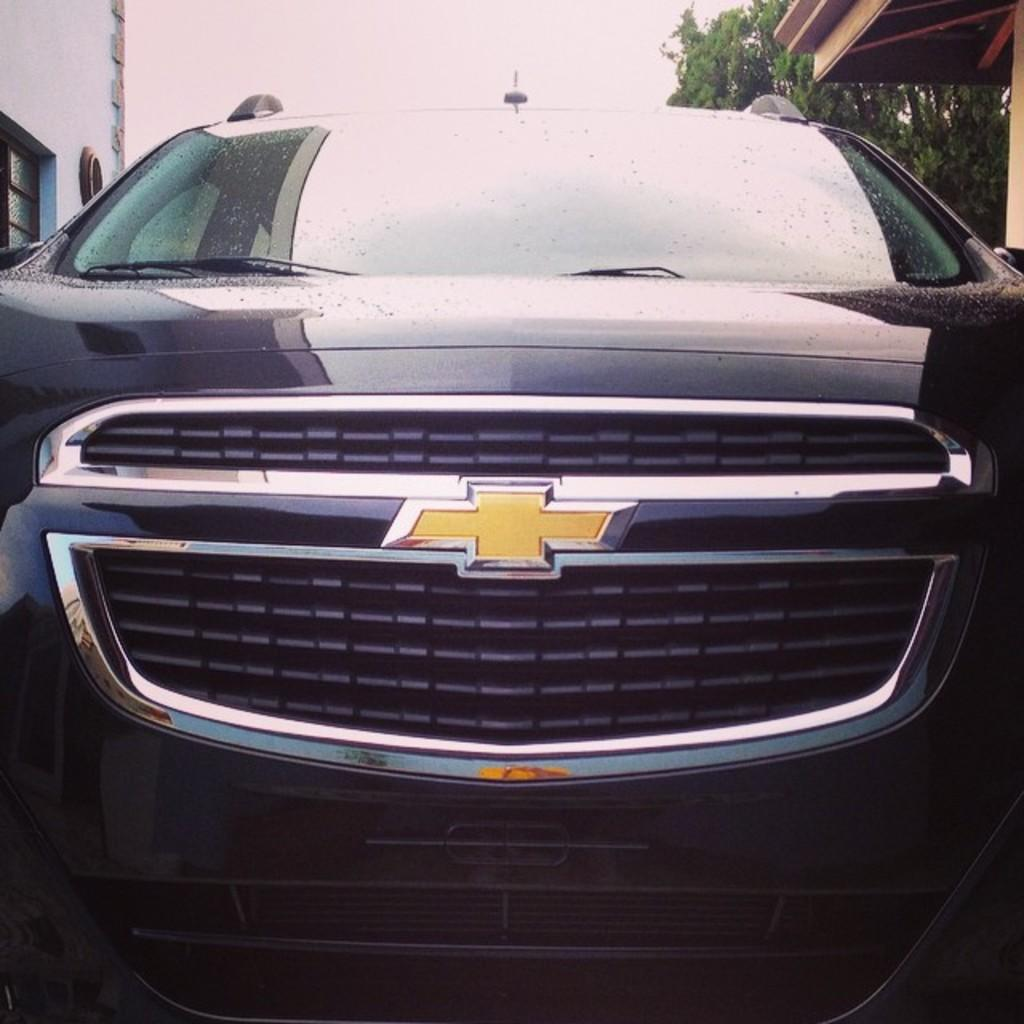What is the main subject of the image? The main subject of the image is a car. What can be seen in the background of the image? There is a wall with a window in the background of the image. What is located on the left side of the image? There is an object on the left side of the image. What is located on the right side of the image? There is a wooden object on the right side of the image. What type of natural elements are visible in the image? Trees and the sky are visible in the image. How many guitars are being played in the image? There are no guitars present in the image. What type of dock can be seen in the image? There is no dock present in the image. 